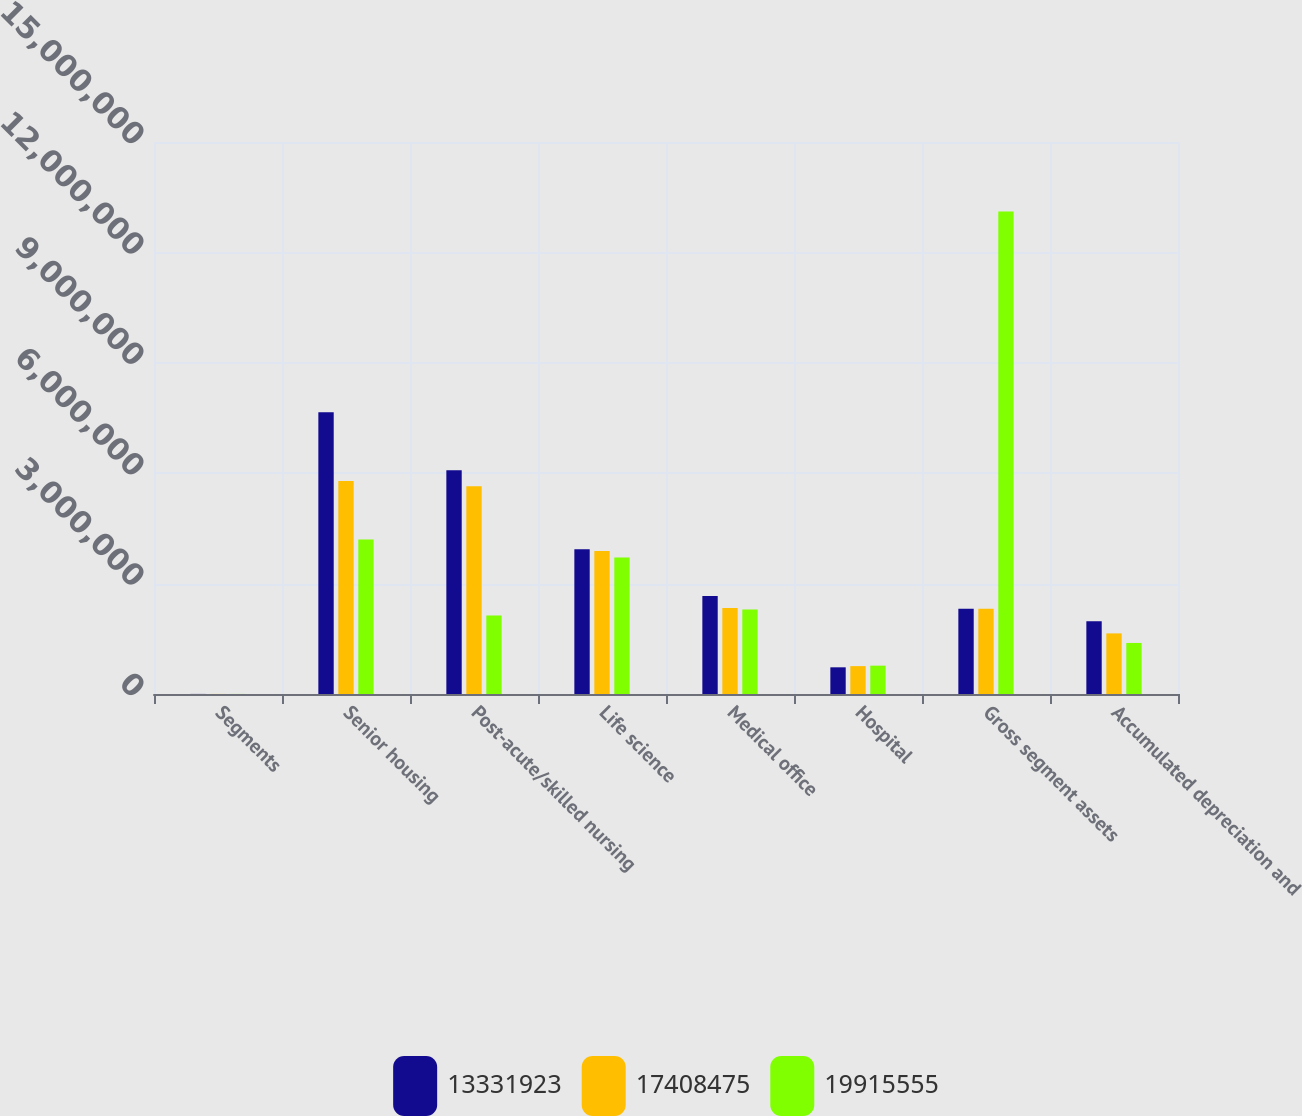Convert chart to OTSL. <chart><loc_0><loc_0><loc_500><loc_500><stacked_bar_chart><ecel><fcel>Segments<fcel>Senior housing<fcel>Post-acute/skilled nursing<fcel>Life science<fcel>Medical office<fcel>Hospital<fcel>Gross segment assets<fcel>Accumulated depreciation and<nl><fcel>1.33319e+07<fcel>2012<fcel>7.65861e+06<fcel>6.08083e+06<fcel>3.9324e+06<fcel>2.66139e+06<fcel>724999<fcel>2.31781e+06<fcel>1.9786e+06<nl><fcel>1.74085e+07<fcel>2011<fcel>5.78544e+06<fcel>5.64447e+06<fcel>3.88685e+06<fcel>2.3363e+06<fcel>757618<fcel>2.31781e+06<fcel>1.64674e+06<nl><fcel>1.99156e+07<fcel>2010<fcel>4.19646e+06<fcel>2.13364e+06<fcel>3.70953e+06<fcel>2.29931e+06<fcel>770038<fcel>1.3109e+07<fcel>1.38685e+06<nl></chart> 